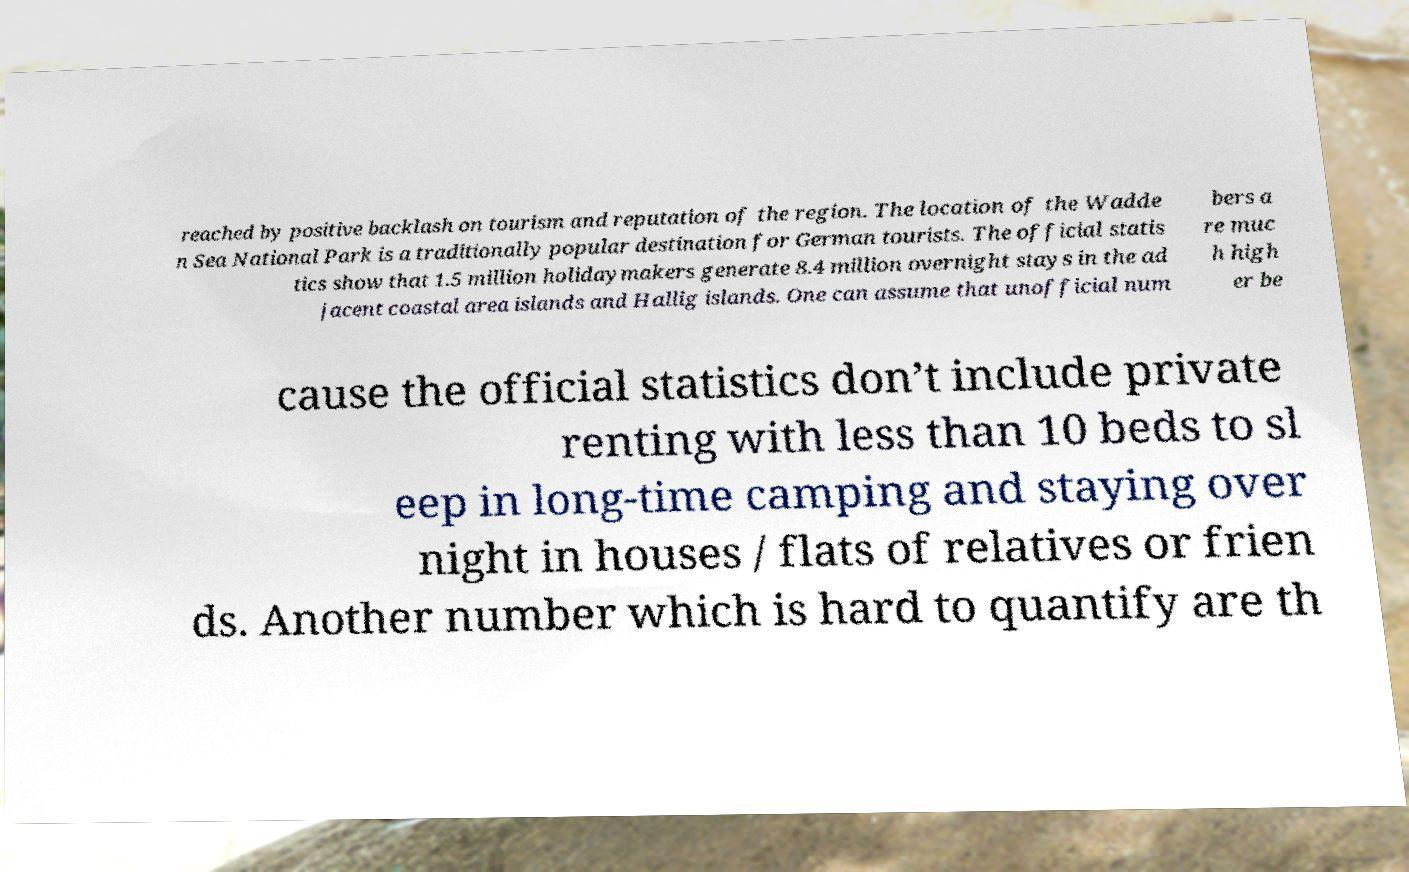Please identify and transcribe the text found in this image. reached by positive backlash on tourism and reputation of the region. The location of the Wadde n Sea National Park is a traditionally popular destination for German tourists. The official statis tics show that 1.5 million holidaymakers generate 8.4 million overnight stays in the ad jacent coastal area islands and Hallig islands. One can assume that unofficial num bers a re muc h high er be cause the official statistics don’t include private renting with less than 10 beds to sl eep in long-time camping and staying over night in houses / flats of relatives or frien ds. Another number which is hard to quantify are th 